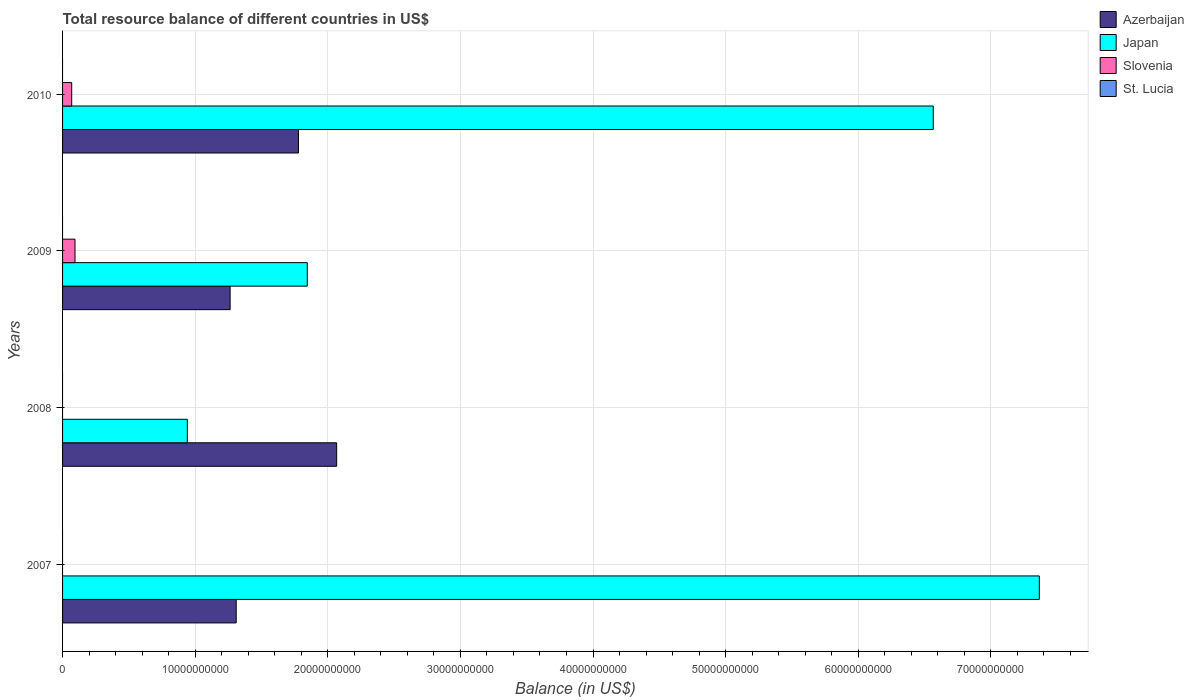How many different coloured bars are there?
Provide a succinct answer. 3. Are the number of bars per tick equal to the number of legend labels?
Provide a succinct answer. No. Are the number of bars on each tick of the Y-axis equal?
Keep it short and to the point. No. How many bars are there on the 1st tick from the top?
Ensure brevity in your answer.  3. What is the label of the 2nd group of bars from the top?
Provide a short and direct response. 2009. What is the total resource balance in Azerbaijan in 2008?
Your answer should be compact. 2.07e+1. Across all years, what is the maximum total resource balance in Slovenia?
Your response must be concise. 9.39e+08. Across all years, what is the minimum total resource balance in St. Lucia?
Offer a very short reply. 0. In which year was the total resource balance in Japan maximum?
Your answer should be compact. 2007. What is the total total resource balance in Japan in the graph?
Offer a terse response. 1.67e+11. What is the difference between the total resource balance in Japan in 2008 and that in 2010?
Give a very brief answer. -5.62e+1. What is the difference between the total resource balance in Azerbaijan in 2010 and the total resource balance in St. Lucia in 2007?
Your response must be concise. 1.78e+1. What is the average total resource balance in Azerbaijan per year?
Offer a very short reply. 1.60e+1. In the year 2010, what is the difference between the total resource balance in Azerbaijan and total resource balance in Japan?
Make the answer very short. -4.79e+1. What is the ratio of the total resource balance in Azerbaijan in 2007 to that in 2008?
Ensure brevity in your answer.  0.63. Is the total resource balance in Japan in 2008 less than that in 2009?
Your answer should be compact. Yes. Is the difference between the total resource balance in Azerbaijan in 2007 and 2008 greater than the difference between the total resource balance in Japan in 2007 and 2008?
Make the answer very short. No. What is the difference between the highest and the second highest total resource balance in Japan?
Your answer should be compact. 8.00e+09. What is the difference between the highest and the lowest total resource balance in Azerbaijan?
Your answer should be compact. 8.03e+09. Are all the bars in the graph horizontal?
Provide a short and direct response. Yes. Are the values on the major ticks of X-axis written in scientific E-notation?
Provide a short and direct response. No. Does the graph contain any zero values?
Your answer should be very brief. Yes. How many legend labels are there?
Offer a terse response. 4. How are the legend labels stacked?
Your answer should be compact. Vertical. What is the title of the graph?
Keep it short and to the point. Total resource balance of different countries in US$. Does "Liechtenstein" appear as one of the legend labels in the graph?
Provide a short and direct response. No. What is the label or title of the X-axis?
Give a very brief answer. Balance (in US$). What is the label or title of the Y-axis?
Your response must be concise. Years. What is the Balance (in US$) of Azerbaijan in 2007?
Offer a very short reply. 1.31e+1. What is the Balance (in US$) of Japan in 2007?
Keep it short and to the point. 7.37e+1. What is the Balance (in US$) of Slovenia in 2007?
Ensure brevity in your answer.  0. What is the Balance (in US$) of St. Lucia in 2007?
Keep it short and to the point. 0. What is the Balance (in US$) in Azerbaijan in 2008?
Your answer should be very brief. 2.07e+1. What is the Balance (in US$) of Japan in 2008?
Offer a very short reply. 9.41e+09. What is the Balance (in US$) in Slovenia in 2008?
Keep it short and to the point. 0. What is the Balance (in US$) in Azerbaijan in 2009?
Your answer should be compact. 1.26e+1. What is the Balance (in US$) in Japan in 2009?
Offer a terse response. 1.85e+1. What is the Balance (in US$) in Slovenia in 2009?
Offer a very short reply. 9.39e+08. What is the Balance (in US$) in Azerbaijan in 2010?
Your answer should be very brief. 1.78e+1. What is the Balance (in US$) of Japan in 2010?
Provide a succinct answer. 6.57e+1. What is the Balance (in US$) in Slovenia in 2010?
Keep it short and to the point. 6.89e+08. What is the Balance (in US$) of St. Lucia in 2010?
Provide a succinct answer. 0. Across all years, what is the maximum Balance (in US$) in Azerbaijan?
Make the answer very short. 2.07e+1. Across all years, what is the maximum Balance (in US$) in Japan?
Provide a short and direct response. 7.37e+1. Across all years, what is the maximum Balance (in US$) in Slovenia?
Make the answer very short. 9.39e+08. Across all years, what is the minimum Balance (in US$) in Azerbaijan?
Provide a succinct answer. 1.26e+1. Across all years, what is the minimum Balance (in US$) in Japan?
Offer a terse response. 9.41e+09. What is the total Balance (in US$) of Azerbaijan in the graph?
Your response must be concise. 6.42e+1. What is the total Balance (in US$) in Japan in the graph?
Ensure brevity in your answer.  1.67e+11. What is the total Balance (in US$) in Slovenia in the graph?
Offer a very short reply. 1.63e+09. What is the difference between the Balance (in US$) in Azerbaijan in 2007 and that in 2008?
Give a very brief answer. -7.58e+09. What is the difference between the Balance (in US$) of Japan in 2007 and that in 2008?
Ensure brevity in your answer.  6.42e+1. What is the difference between the Balance (in US$) of Azerbaijan in 2007 and that in 2009?
Your answer should be very brief. 4.58e+08. What is the difference between the Balance (in US$) of Japan in 2007 and that in 2009?
Keep it short and to the point. 5.52e+1. What is the difference between the Balance (in US$) of Azerbaijan in 2007 and that in 2010?
Make the answer very short. -4.69e+09. What is the difference between the Balance (in US$) of Japan in 2007 and that in 2010?
Ensure brevity in your answer.  8.00e+09. What is the difference between the Balance (in US$) in Azerbaijan in 2008 and that in 2009?
Keep it short and to the point. 8.03e+09. What is the difference between the Balance (in US$) of Japan in 2008 and that in 2009?
Ensure brevity in your answer.  -9.05e+09. What is the difference between the Balance (in US$) of Azerbaijan in 2008 and that in 2010?
Provide a succinct answer. 2.88e+09. What is the difference between the Balance (in US$) of Japan in 2008 and that in 2010?
Provide a short and direct response. -5.62e+1. What is the difference between the Balance (in US$) of Azerbaijan in 2009 and that in 2010?
Ensure brevity in your answer.  -5.15e+09. What is the difference between the Balance (in US$) in Japan in 2009 and that in 2010?
Your answer should be very brief. -4.72e+1. What is the difference between the Balance (in US$) in Slovenia in 2009 and that in 2010?
Give a very brief answer. 2.50e+08. What is the difference between the Balance (in US$) in Azerbaijan in 2007 and the Balance (in US$) in Japan in 2008?
Your answer should be compact. 3.69e+09. What is the difference between the Balance (in US$) of Azerbaijan in 2007 and the Balance (in US$) of Japan in 2009?
Your answer should be very brief. -5.36e+09. What is the difference between the Balance (in US$) in Azerbaijan in 2007 and the Balance (in US$) in Slovenia in 2009?
Keep it short and to the point. 1.22e+1. What is the difference between the Balance (in US$) in Japan in 2007 and the Balance (in US$) in Slovenia in 2009?
Your answer should be very brief. 7.27e+1. What is the difference between the Balance (in US$) of Azerbaijan in 2007 and the Balance (in US$) of Japan in 2010?
Keep it short and to the point. -5.26e+1. What is the difference between the Balance (in US$) in Azerbaijan in 2007 and the Balance (in US$) in Slovenia in 2010?
Offer a terse response. 1.24e+1. What is the difference between the Balance (in US$) of Japan in 2007 and the Balance (in US$) of Slovenia in 2010?
Give a very brief answer. 7.30e+1. What is the difference between the Balance (in US$) of Azerbaijan in 2008 and the Balance (in US$) of Japan in 2009?
Your answer should be compact. 2.22e+09. What is the difference between the Balance (in US$) of Azerbaijan in 2008 and the Balance (in US$) of Slovenia in 2009?
Offer a terse response. 1.97e+1. What is the difference between the Balance (in US$) in Japan in 2008 and the Balance (in US$) in Slovenia in 2009?
Offer a terse response. 8.47e+09. What is the difference between the Balance (in US$) in Azerbaijan in 2008 and the Balance (in US$) in Japan in 2010?
Offer a terse response. -4.50e+1. What is the difference between the Balance (in US$) in Azerbaijan in 2008 and the Balance (in US$) in Slovenia in 2010?
Your answer should be very brief. 2.00e+1. What is the difference between the Balance (in US$) in Japan in 2008 and the Balance (in US$) in Slovenia in 2010?
Offer a terse response. 8.72e+09. What is the difference between the Balance (in US$) of Azerbaijan in 2009 and the Balance (in US$) of Japan in 2010?
Give a very brief answer. -5.30e+1. What is the difference between the Balance (in US$) of Azerbaijan in 2009 and the Balance (in US$) of Slovenia in 2010?
Provide a succinct answer. 1.19e+1. What is the difference between the Balance (in US$) of Japan in 2009 and the Balance (in US$) of Slovenia in 2010?
Provide a succinct answer. 1.78e+1. What is the average Balance (in US$) in Azerbaijan per year?
Your response must be concise. 1.60e+1. What is the average Balance (in US$) of Japan per year?
Your response must be concise. 4.18e+1. What is the average Balance (in US$) in Slovenia per year?
Your response must be concise. 4.07e+08. What is the average Balance (in US$) in St. Lucia per year?
Your answer should be compact. 0. In the year 2007, what is the difference between the Balance (in US$) in Azerbaijan and Balance (in US$) in Japan?
Provide a succinct answer. -6.06e+1. In the year 2008, what is the difference between the Balance (in US$) in Azerbaijan and Balance (in US$) in Japan?
Your answer should be compact. 1.13e+1. In the year 2009, what is the difference between the Balance (in US$) of Azerbaijan and Balance (in US$) of Japan?
Your response must be concise. -5.82e+09. In the year 2009, what is the difference between the Balance (in US$) of Azerbaijan and Balance (in US$) of Slovenia?
Your response must be concise. 1.17e+1. In the year 2009, what is the difference between the Balance (in US$) in Japan and Balance (in US$) in Slovenia?
Offer a terse response. 1.75e+1. In the year 2010, what is the difference between the Balance (in US$) in Azerbaijan and Balance (in US$) in Japan?
Give a very brief answer. -4.79e+1. In the year 2010, what is the difference between the Balance (in US$) of Azerbaijan and Balance (in US$) of Slovenia?
Give a very brief answer. 1.71e+1. In the year 2010, what is the difference between the Balance (in US$) in Japan and Balance (in US$) in Slovenia?
Make the answer very short. 6.50e+1. What is the ratio of the Balance (in US$) in Azerbaijan in 2007 to that in 2008?
Your response must be concise. 0.63. What is the ratio of the Balance (in US$) of Japan in 2007 to that in 2008?
Make the answer very short. 7.83. What is the ratio of the Balance (in US$) in Azerbaijan in 2007 to that in 2009?
Your answer should be compact. 1.04. What is the ratio of the Balance (in US$) in Japan in 2007 to that in 2009?
Your response must be concise. 3.99. What is the ratio of the Balance (in US$) in Azerbaijan in 2007 to that in 2010?
Offer a terse response. 0.74. What is the ratio of the Balance (in US$) in Japan in 2007 to that in 2010?
Offer a terse response. 1.12. What is the ratio of the Balance (in US$) in Azerbaijan in 2008 to that in 2009?
Give a very brief answer. 1.64. What is the ratio of the Balance (in US$) of Japan in 2008 to that in 2009?
Your response must be concise. 0.51. What is the ratio of the Balance (in US$) in Azerbaijan in 2008 to that in 2010?
Your answer should be compact. 1.16. What is the ratio of the Balance (in US$) of Japan in 2008 to that in 2010?
Provide a succinct answer. 0.14. What is the ratio of the Balance (in US$) of Azerbaijan in 2009 to that in 2010?
Offer a very short reply. 0.71. What is the ratio of the Balance (in US$) of Japan in 2009 to that in 2010?
Give a very brief answer. 0.28. What is the ratio of the Balance (in US$) of Slovenia in 2009 to that in 2010?
Provide a short and direct response. 1.36. What is the difference between the highest and the second highest Balance (in US$) in Azerbaijan?
Give a very brief answer. 2.88e+09. What is the difference between the highest and the second highest Balance (in US$) in Japan?
Provide a succinct answer. 8.00e+09. What is the difference between the highest and the lowest Balance (in US$) of Azerbaijan?
Provide a short and direct response. 8.03e+09. What is the difference between the highest and the lowest Balance (in US$) of Japan?
Keep it short and to the point. 6.42e+1. What is the difference between the highest and the lowest Balance (in US$) in Slovenia?
Offer a terse response. 9.39e+08. 